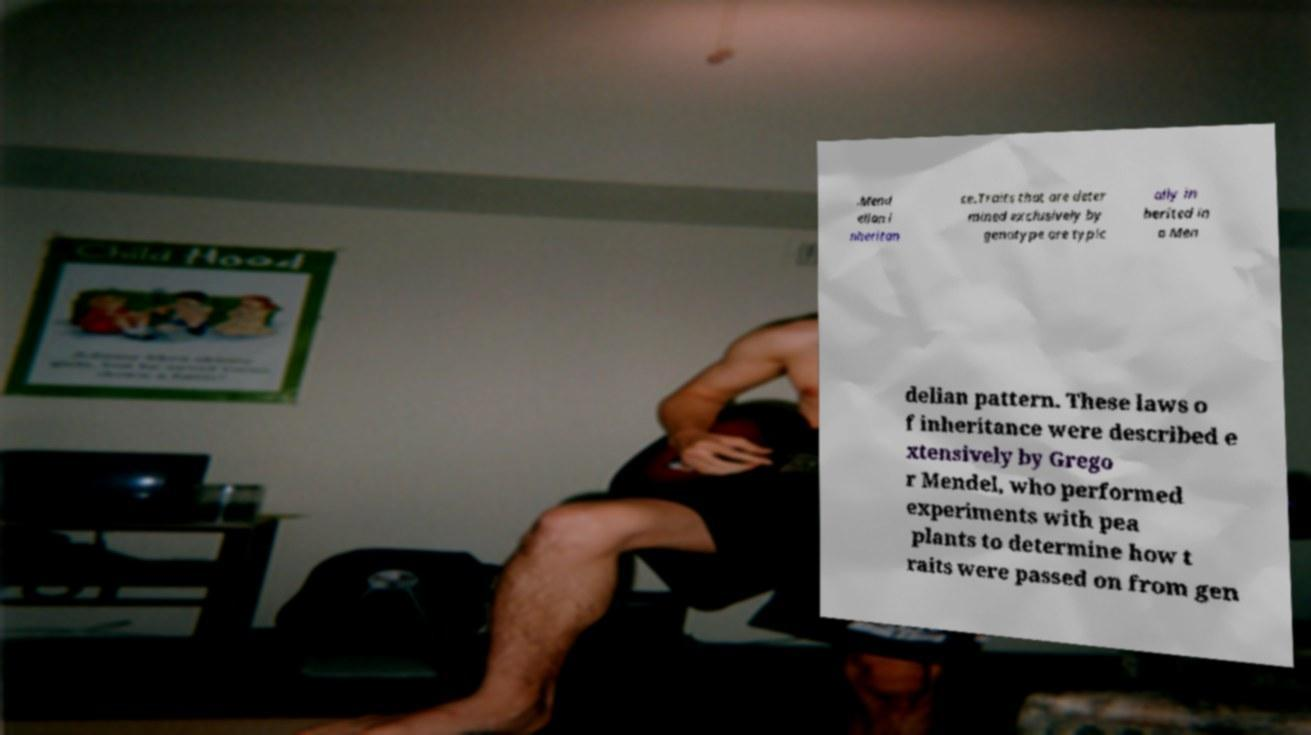What messages or text are displayed in this image? I need them in a readable, typed format. .Mend elian i nheritan ce.Traits that are deter mined exclusively by genotype are typic ally in herited in a Men delian pattern. These laws o f inheritance were described e xtensively by Grego r Mendel, who performed experiments with pea plants to determine how t raits were passed on from gen 